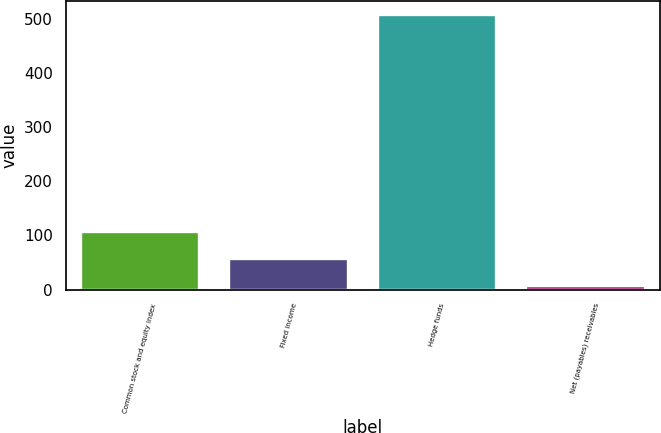Convert chart to OTSL. <chart><loc_0><loc_0><loc_500><loc_500><bar_chart><fcel>Common stock and equity index<fcel>Fixed income<fcel>Hedge funds<fcel>Net (payables) receivables<nl><fcel>106.2<fcel>56.1<fcel>507<fcel>6<nl></chart> 